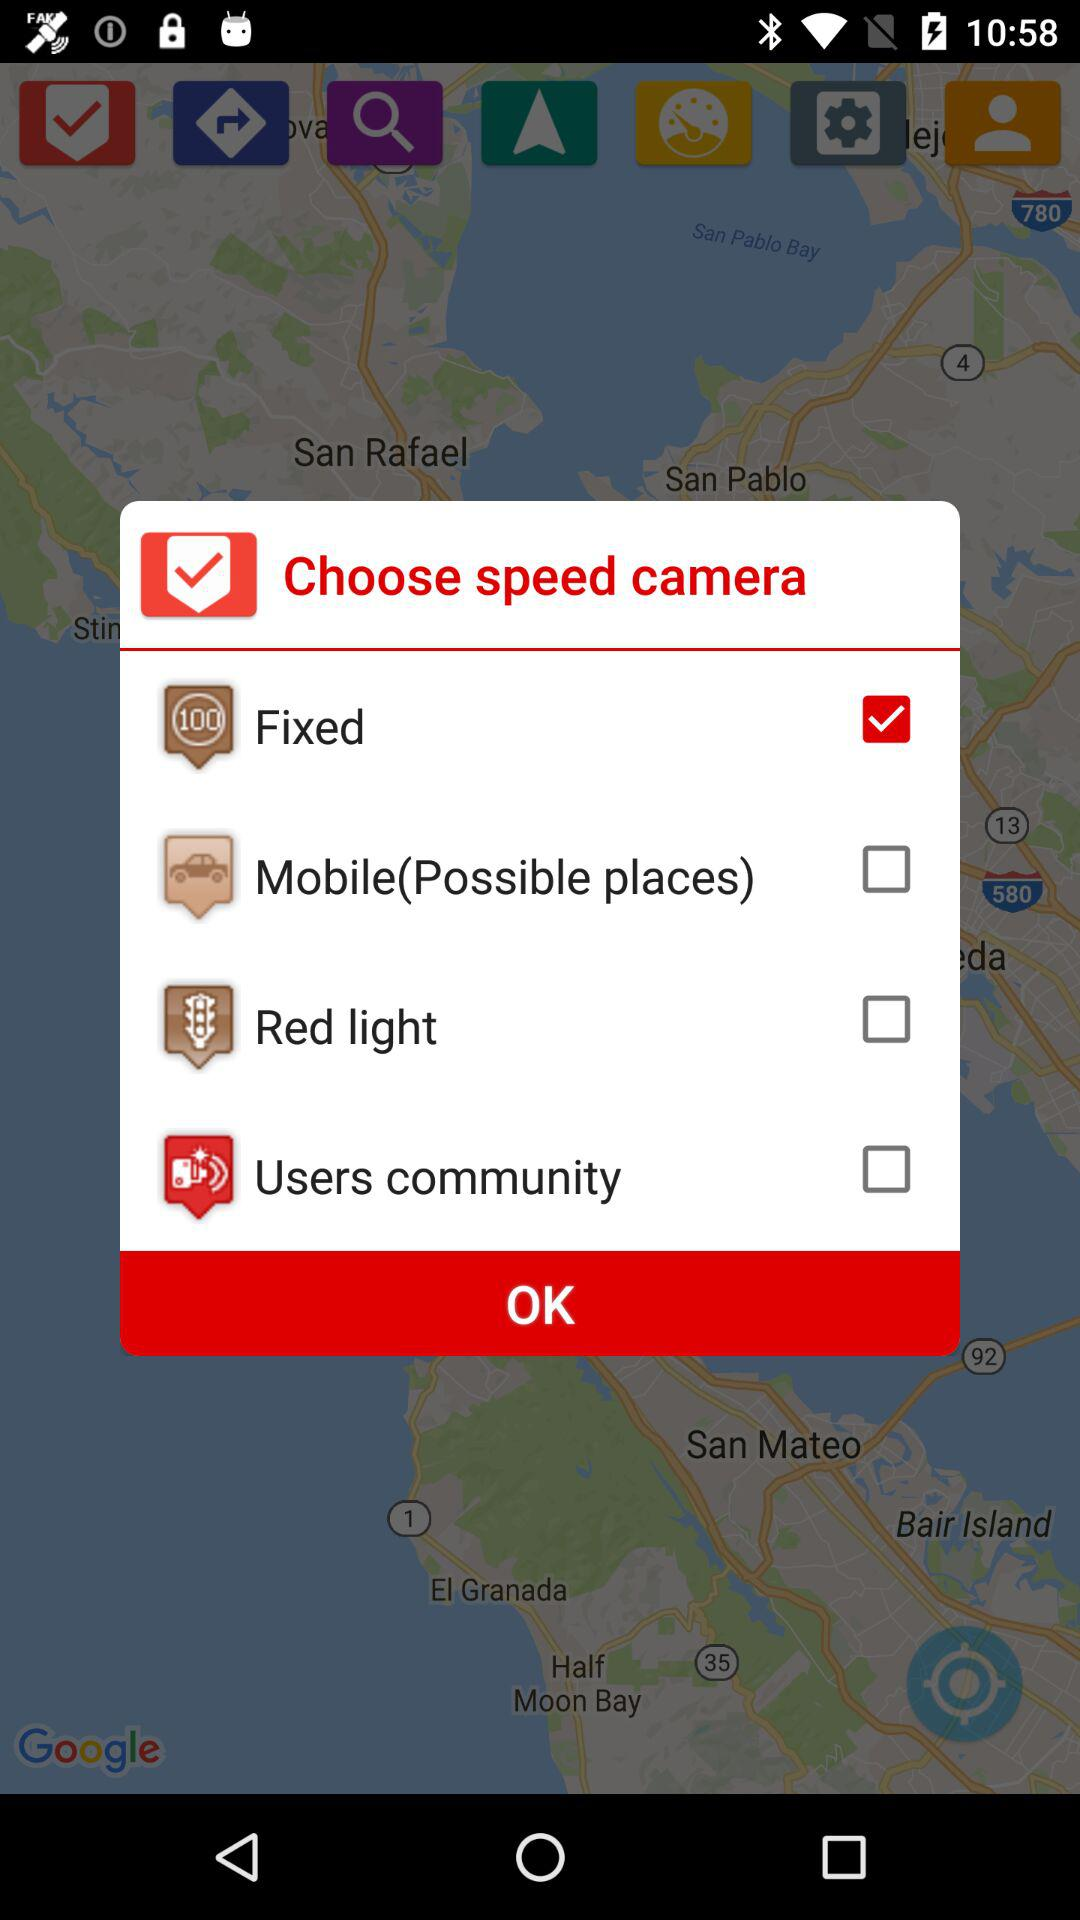Which are the selected options? The selected option is "Fixed". 